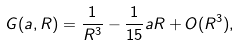Convert formula to latex. <formula><loc_0><loc_0><loc_500><loc_500>G ( \L a , R ) = \frac { 1 } { R ^ { 3 } } - \frac { 1 } { 1 5 } \L a R + O ( R ^ { 3 } ) ,</formula> 